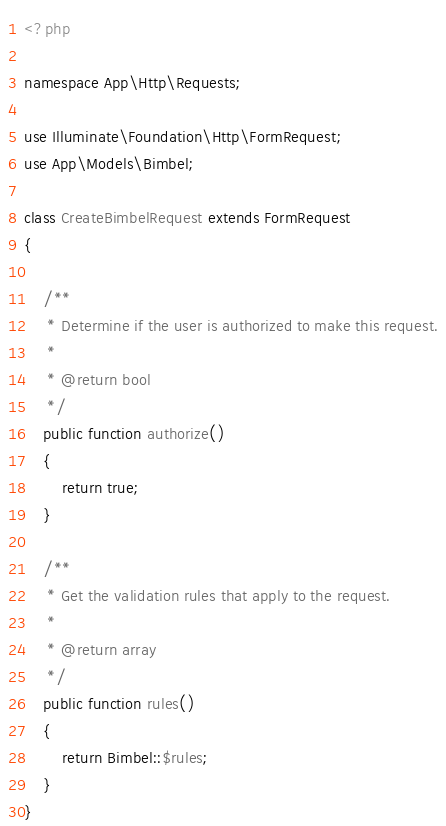Convert code to text. <code><loc_0><loc_0><loc_500><loc_500><_PHP_><?php

namespace App\Http\Requests;

use Illuminate\Foundation\Http\FormRequest;
use App\Models\Bimbel;

class CreateBimbelRequest extends FormRequest
{

    /**
     * Determine if the user is authorized to make this request.
     *
     * @return bool
     */
    public function authorize()
    {
        return true;
    }

    /**
     * Get the validation rules that apply to the request.
     *
     * @return array
     */
    public function rules()
    {
        return Bimbel::$rules;
    }
}
</code> 